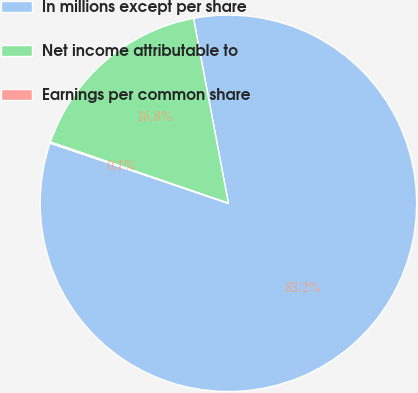<chart> <loc_0><loc_0><loc_500><loc_500><pie_chart><fcel>In millions except per share<fcel>Net income attributable to<fcel>Earnings per common share<nl><fcel>83.15%<fcel>16.75%<fcel>0.1%<nl></chart> 